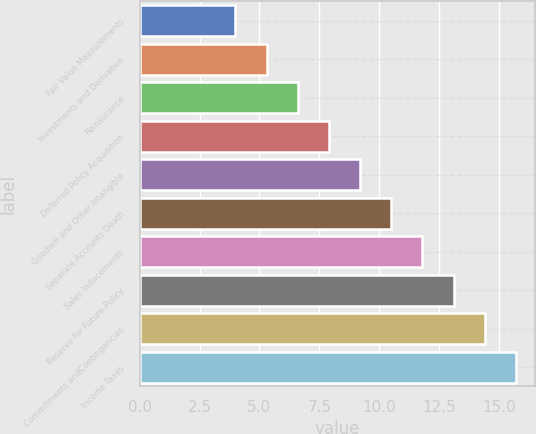<chart> <loc_0><loc_0><loc_500><loc_500><bar_chart><fcel>Fair Value Measurements<fcel>Investments and Derivative<fcel>Reinsurance<fcel>Deferred Policy Acquisition<fcel>Goodwill and Other Intangible<fcel>Separate Accounts Death<fcel>Sales Inducements<fcel>Reserve for Future Policy<fcel>Commitments andContingencies<fcel>Income Taxes<nl><fcel>4<fcel>5.3<fcel>6.6<fcel>7.9<fcel>9.2<fcel>10.5<fcel>11.8<fcel>13.1<fcel>14.4<fcel>15.7<nl></chart> 